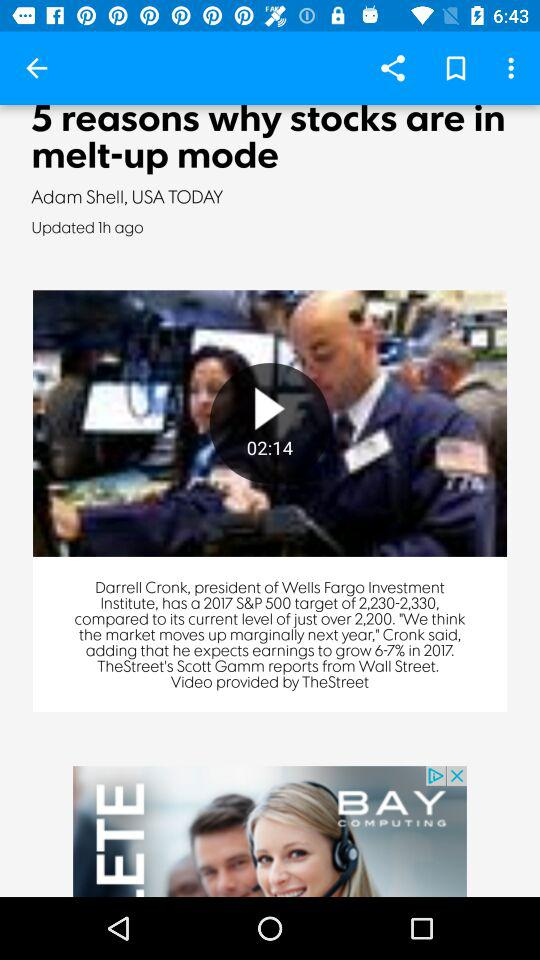Who is the author? The author is Adam Shell. 